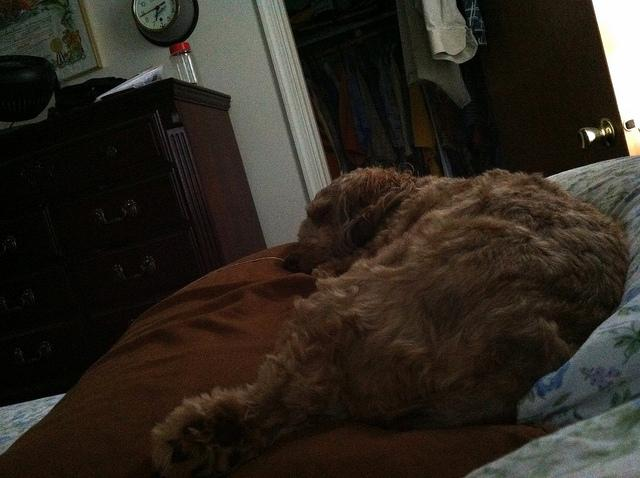What is on the bed?

Choices:
A) pet
B) woman
C) man
D) single rose pet 